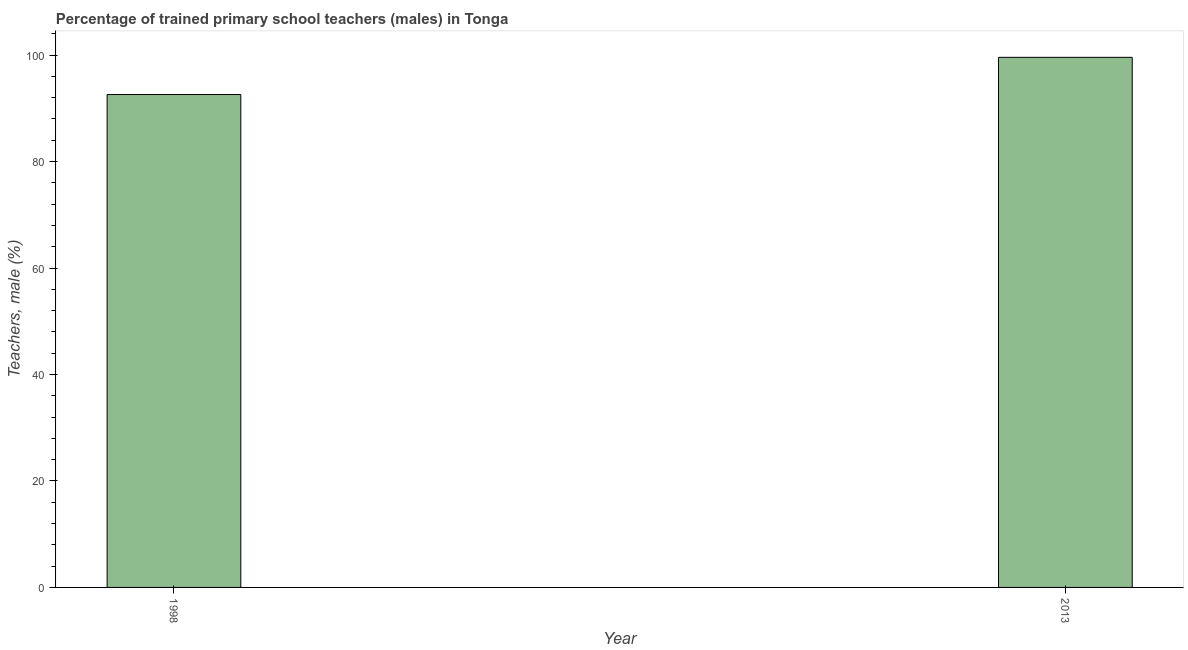Does the graph contain any zero values?
Your response must be concise. No. What is the title of the graph?
Make the answer very short. Percentage of trained primary school teachers (males) in Tonga. What is the label or title of the Y-axis?
Keep it short and to the point. Teachers, male (%). What is the percentage of trained male teachers in 2013?
Your response must be concise. 99.58. Across all years, what is the maximum percentage of trained male teachers?
Offer a terse response. 99.58. Across all years, what is the minimum percentage of trained male teachers?
Provide a succinct answer. 92.59. In which year was the percentage of trained male teachers maximum?
Offer a terse response. 2013. In which year was the percentage of trained male teachers minimum?
Ensure brevity in your answer.  1998. What is the sum of the percentage of trained male teachers?
Your response must be concise. 192.16. What is the difference between the percentage of trained male teachers in 1998 and 2013?
Offer a very short reply. -6.99. What is the average percentage of trained male teachers per year?
Your answer should be very brief. 96.08. What is the median percentage of trained male teachers?
Offer a very short reply. 96.08. In how many years, is the percentage of trained male teachers greater than 4 %?
Ensure brevity in your answer.  2. Do a majority of the years between 1998 and 2013 (inclusive) have percentage of trained male teachers greater than 56 %?
Your response must be concise. Yes. What is the ratio of the percentage of trained male teachers in 1998 to that in 2013?
Keep it short and to the point. 0.93. Are all the bars in the graph horizontal?
Offer a very short reply. No. How many years are there in the graph?
Make the answer very short. 2. What is the difference between two consecutive major ticks on the Y-axis?
Make the answer very short. 20. What is the Teachers, male (%) in 1998?
Provide a short and direct response. 92.59. What is the Teachers, male (%) of 2013?
Offer a very short reply. 99.58. What is the difference between the Teachers, male (%) in 1998 and 2013?
Your response must be concise. -6.99. 